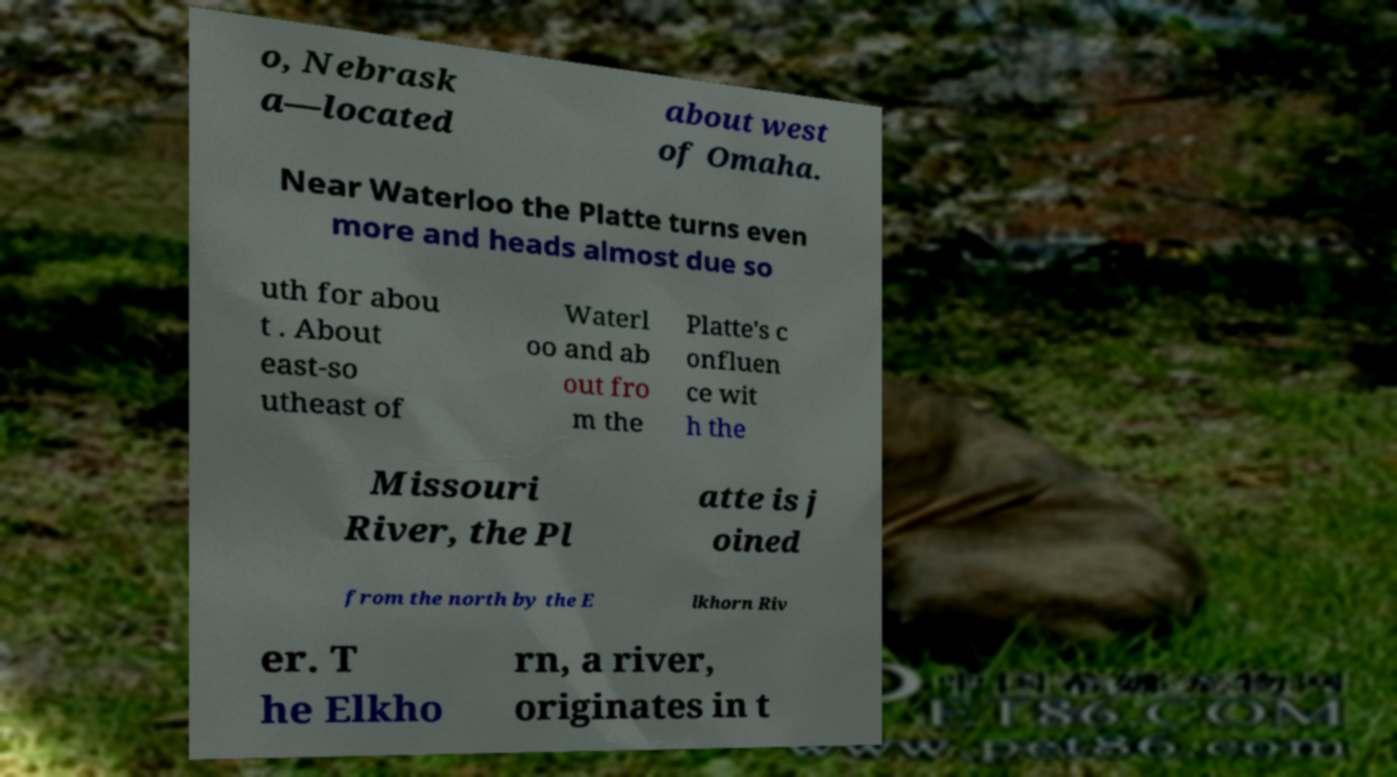Can you accurately transcribe the text from the provided image for me? o, Nebrask a—located about west of Omaha. Near Waterloo the Platte turns even more and heads almost due so uth for abou t . About east-so utheast of Waterl oo and ab out fro m the Platte's c onfluen ce wit h the Missouri River, the Pl atte is j oined from the north by the E lkhorn Riv er. T he Elkho rn, a river, originates in t 